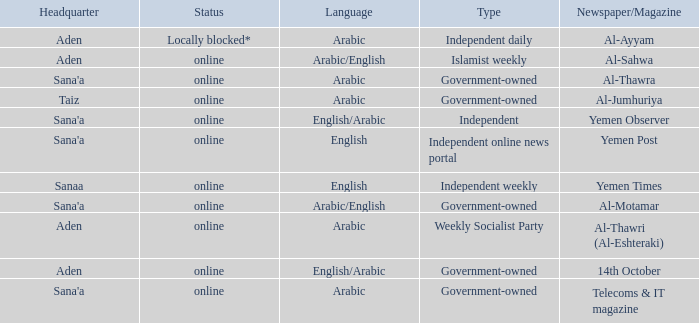What is Headquarter, when Type is Independent Online News Portal? Sana'a. 